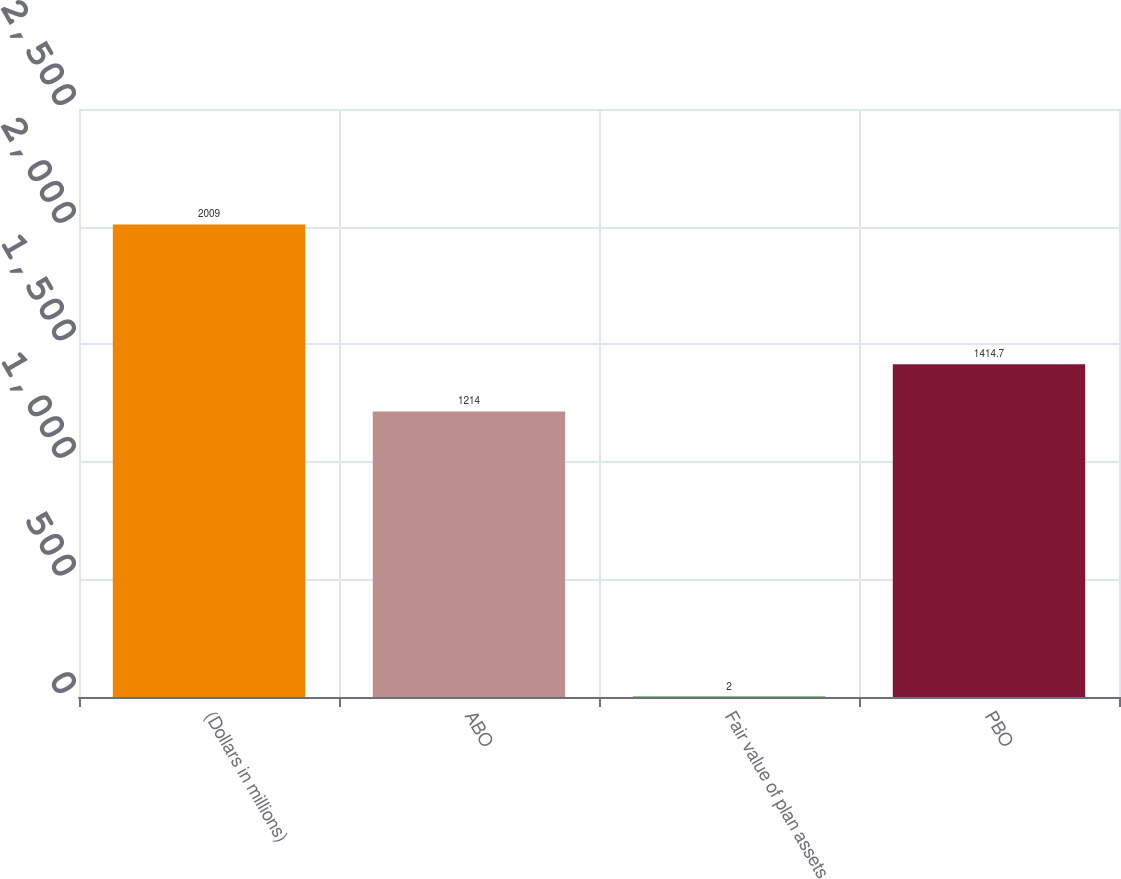<chart> <loc_0><loc_0><loc_500><loc_500><bar_chart><fcel>(Dollars in millions)<fcel>ABO<fcel>Fair value of plan assets<fcel>PBO<nl><fcel>2009<fcel>1214<fcel>2<fcel>1414.7<nl></chart> 